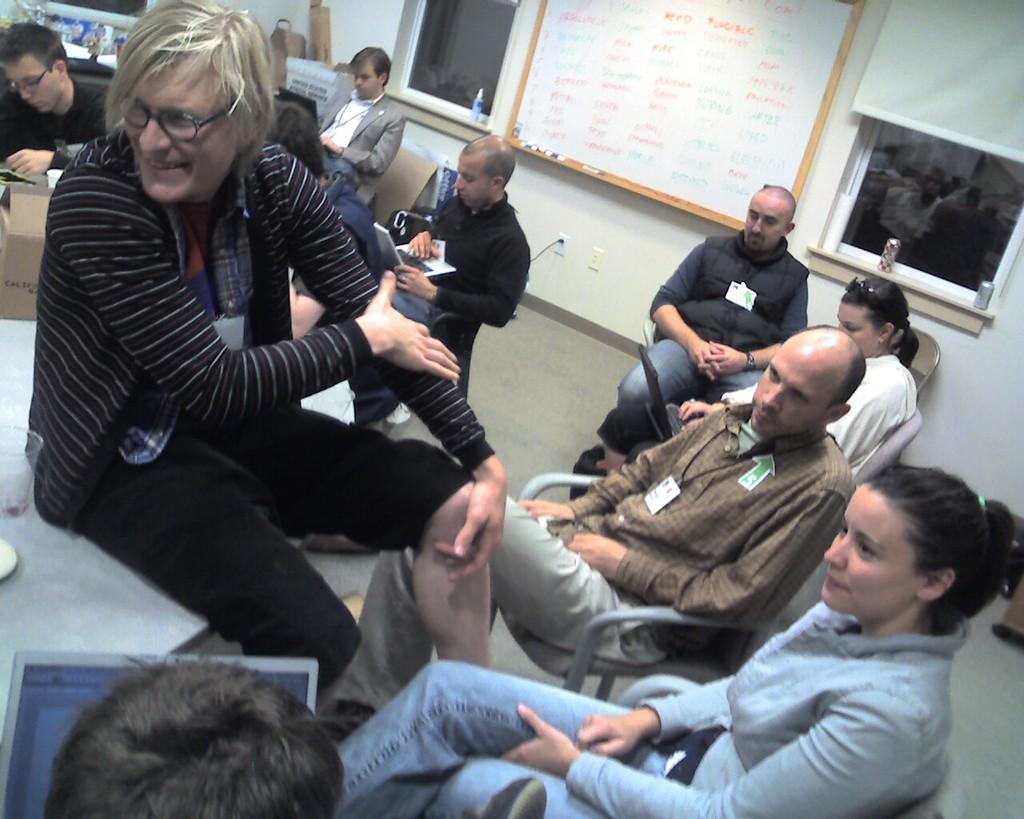Describe this image in one or two sentences. In this image in the middle, there is a man, he wears a t shirt, trouser, he is sitting on the table. At the bottom there is a woman, she wears a shirt, trouser, she is sitting on the chair. On the right there is a man, he wears a shirt, trouser, he is sitting on the chair, behind him there is a woman, she wears a shirt, she is sitting on the chair and there are some people. In the background there are windows, curtain, white board, markers and wall. 